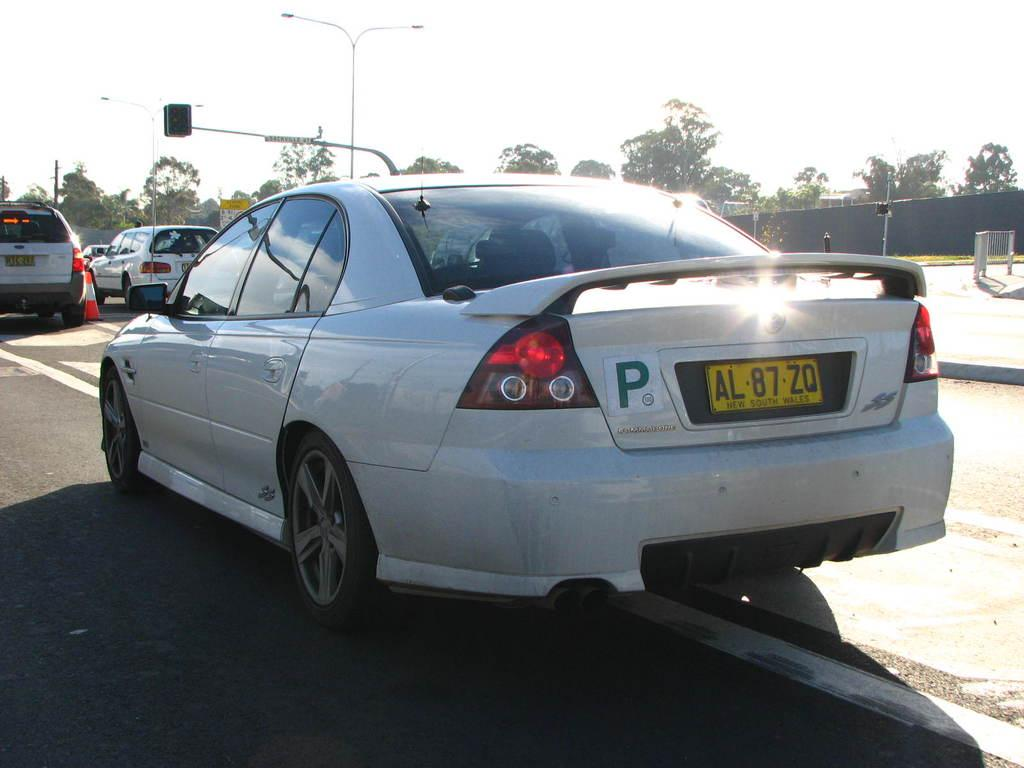What type of vehicles can be seen on the road in the image? There are cars on the road in the image. What other objects can be seen in the image besides cars? There are trees and poles in the image. What is visible at the top of the image? The sky is visible at the top of the image. Can you tell me which actor is sitting in the car on the right side of the image? There is no actor present in the image, and we cannot determine who might be sitting in the car. What type of tongue can be seen hanging from the tree in the image? There is no tongue present in the image; it features cars, trees, and poles. 